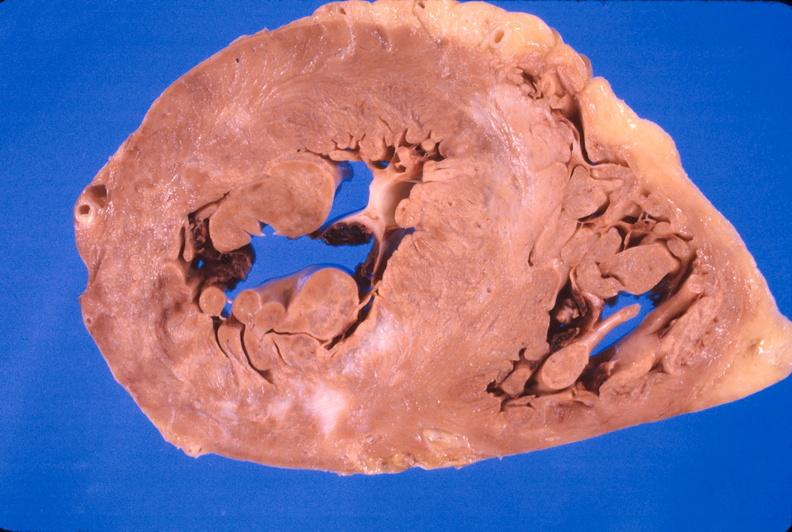s cardiovascular present?
Answer the question using a single word or phrase. Yes 